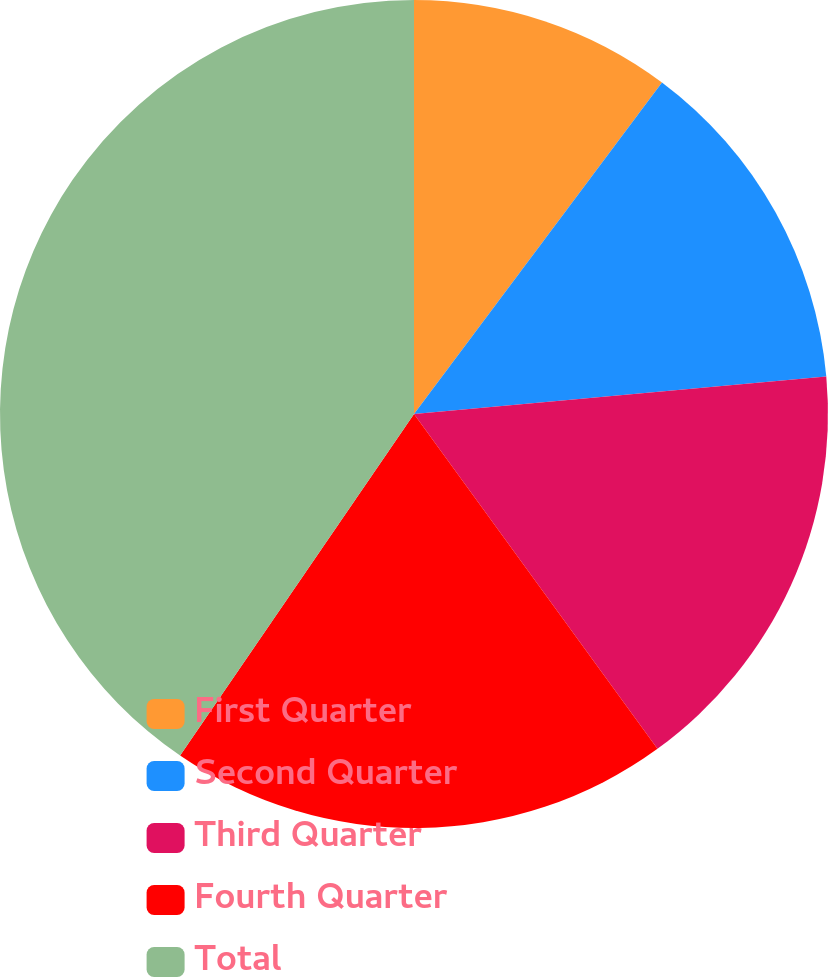Convert chart to OTSL. <chart><loc_0><loc_0><loc_500><loc_500><pie_chart><fcel>First Quarter<fcel>Second Quarter<fcel>Third Quarter<fcel>Fourth Quarter<fcel>Total<nl><fcel>10.22%<fcel>13.33%<fcel>16.44%<fcel>19.56%<fcel>40.44%<nl></chart> 